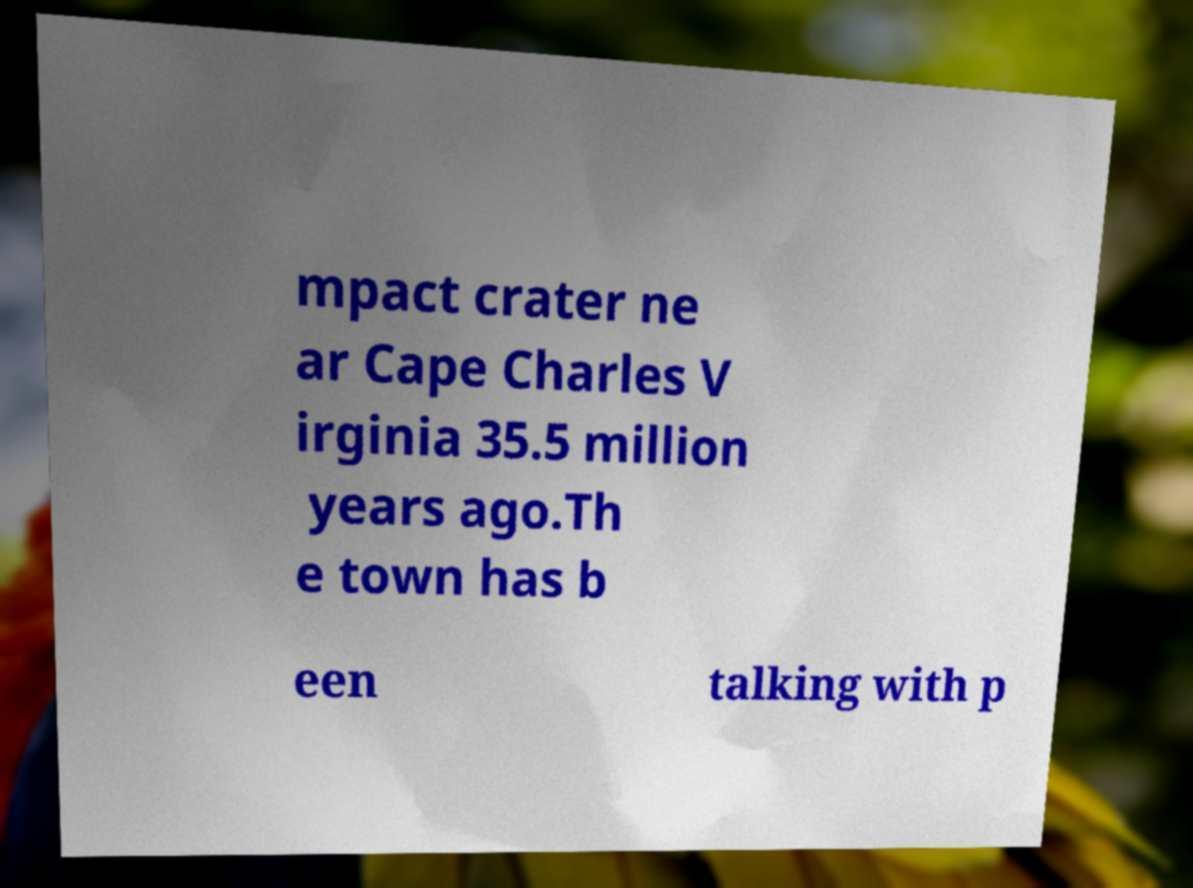Can you accurately transcribe the text from the provided image for me? mpact crater ne ar Cape Charles V irginia 35.5 million years ago.Th e town has b een talking with p 